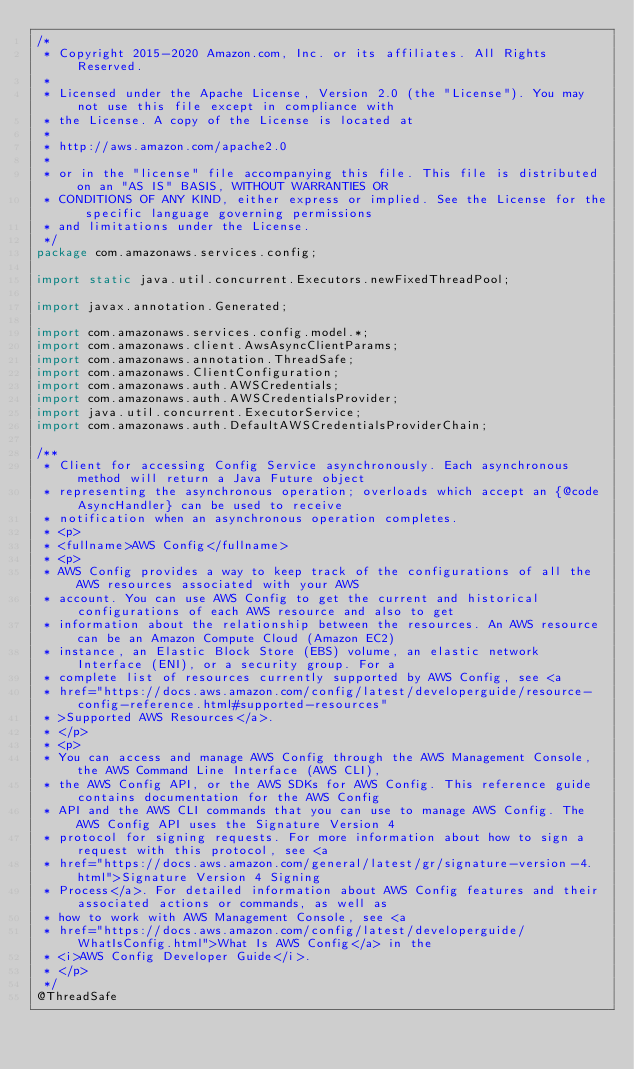Convert code to text. <code><loc_0><loc_0><loc_500><loc_500><_Java_>/*
 * Copyright 2015-2020 Amazon.com, Inc. or its affiliates. All Rights Reserved.
 * 
 * Licensed under the Apache License, Version 2.0 (the "License"). You may not use this file except in compliance with
 * the License. A copy of the License is located at
 * 
 * http://aws.amazon.com/apache2.0
 * 
 * or in the "license" file accompanying this file. This file is distributed on an "AS IS" BASIS, WITHOUT WARRANTIES OR
 * CONDITIONS OF ANY KIND, either express or implied. See the License for the specific language governing permissions
 * and limitations under the License.
 */
package com.amazonaws.services.config;

import static java.util.concurrent.Executors.newFixedThreadPool;

import javax.annotation.Generated;

import com.amazonaws.services.config.model.*;
import com.amazonaws.client.AwsAsyncClientParams;
import com.amazonaws.annotation.ThreadSafe;
import com.amazonaws.ClientConfiguration;
import com.amazonaws.auth.AWSCredentials;
import com.amazonaws.auth.AWSCredentialsProvider;
import java.util.concurrent.ExecutorService;
import com.amazonaws.auth.DefaultAWSCredentialsProviderChain;

/**
 * Client for accessing Config Service asynchronously. Each asynchronous method will return a Java Future object
 * representing the asynchronous operation; overloads which accept an {@code AsyncHandler} can be used to receive
 * notification when an asynchronous operation completes.
 * <p>
 * <fullname>AWS Config</fullname>
 * <p>
 * AWS Config provides a way to keep track of the configurations of all the AWS resources associated with your AWS
 * account. You can use AWS Config to get the current and historical configurations of each AWS resource and also to get
 * information about the relationship between the resources. An AWS resource can be an Amazon Compute Cloud (Amazon EC2)
 * instance, an Elastic Block Store (EBS) volume, an elastic network Interface (ENI), or a security group. For a
 * complete list of resources currently supported by AWS Config, see <a
 * href="https://docs.aws.amazon.com/config/latest/developerguide/resource-config-reference.html#supported-resources"
 * >Supported AWS Resources</a>.
 * </p>
 * <p>
 * You can access and manage AWS Config through the AWS Management Console, the AWS Command Line Interface (AWS CLI),
 * the AWS Config API, or the AWS SDKs for AWS Config. This reference guide contains documentation for the AWS Config
 * API and the AWS CLI commands that you can use to manage AWS Config. The AWS Config API uses the Signature Version 4
 * protocol for signing requests. For more information about how to sign a request with this protocol, see <a
 * href="https://docs.aws.amazon.com/general/latest/gr/signature-version-4.html">Signature Version 4 Signing
 * Process</a>. For detailed information about AWS Config features and their associated actions or commands, as well as
 * how to work with AWS Management Console, see <a
 * href="https://docs.aws.amazon.com/config/latest/developerguide/WhatIsConfig.html">What Is AWS Config</a> in the
 * <i>AWS Config Developer Guide</i>.
 * </p>
 */
@ThreadSafe</code> 